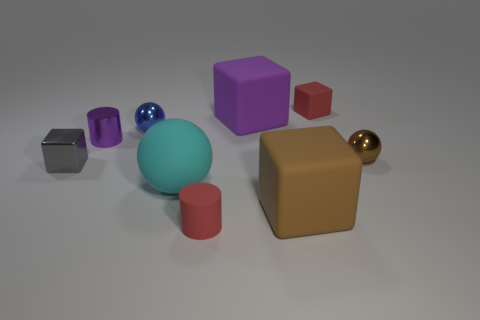How many tiny brown metallic balls are in front of the small red rubber cylinder?
Make the answer very short. 0. What is the color of the small block behind the large matte thing that is behind the metallic block?
Give a very brief answer. Red. How many other things are there of the same material as the cyan sphere?
Your answer should be compact. 4. Are there an equal number of big matte cubes to the left of the small purple shiny object and purple shiny cylinders?
Offer a terse response. No. There is a cylinder on the left side of the sphere that is behind the small metallic sphere on the right side of the small red block; what is its material?
Ensure brevity in your answer.  Metal. What is the color of the small matte thing in front of the big matte ball?
Ensure brevity in your answer.  Red. Is there anything else that is the same shape as the tiny blue object?
Your answer should be compact. Yes. What size is the purple thing behind the cylinder that is behind the tiny shiny block?
Your answer should be compact. Large. Are there an equal number of small cylinders on the right side of the brown matte cube and large purple matte blocks left of the matte cylinder?
Provide a succinct answer. Yes. Is there any other thing that has the same size as the brown cube?
Keep it short and to the point. Yes. 